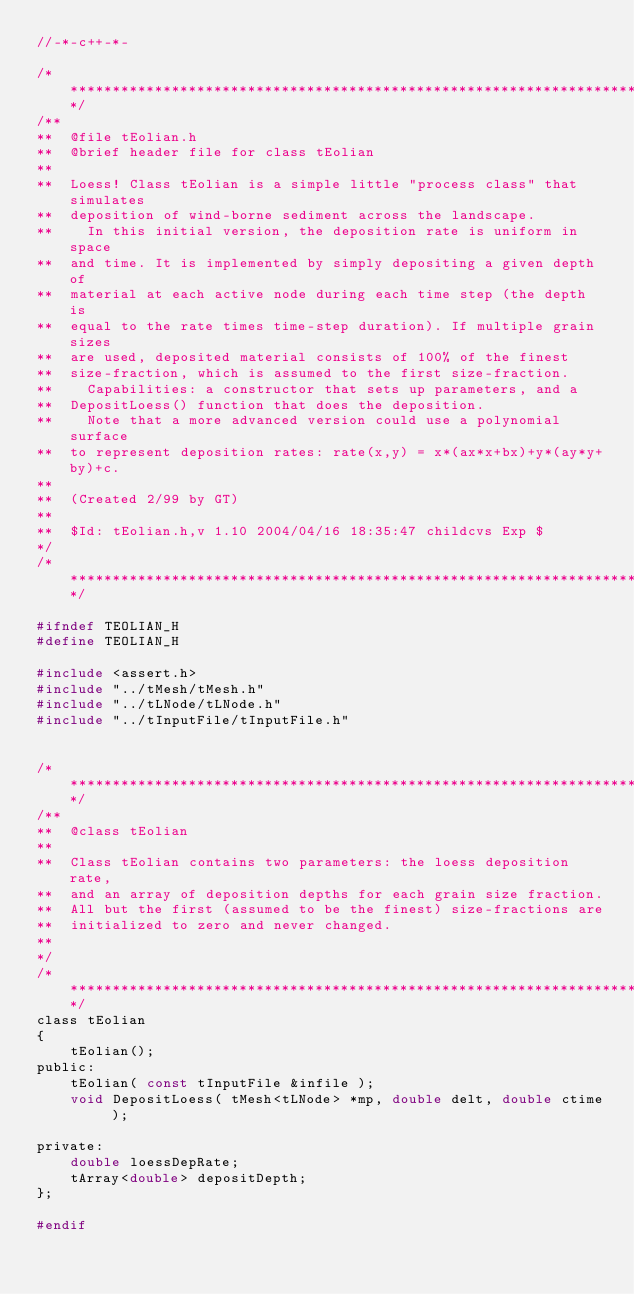<code> <loc_0><loc_0><loc_500><loc_500><_C_>//-*-c++-*- 

/**************************************************************************/
/**
**  @file tEolian.h
**  @brief header file for class tEolian
**
**  Loess! Class tEolian is a simple little "process class" that simulates
**  deposition of wind-borne sediment across the landscape.
**    In this initial version, the deposition rate is uniform in space
**  and time. It is implemented by simply depositing a given depth of
**  material at each active node during each time step (the depth is
**  equal to the rate times time-step duration). If multiple grain sizes
**  are used, deposited material consists of 100% of the finest
**  size-fraction, which is assumed to the first size-fraction.
**    Capabilities: a constructor that sets up parameters, and a
**  DepositLoess() function that does the deposition.
**    Note that a more advanced version could use a polynomial surface
**  to represent deposition rates: rate(x,y) = x*(ax*x+bx)+y*(ay*y+by)+c.
**
**  (Created 2/99 by GT)
**
**  $Id: tEolian.h,v 1.10 2004/04/16 18:35:47 childcvs Exp $
*/
/**************************************************************************/

#ifndef TEOLIAN_H
#define TEOLIAN_H

#include <assert.h>
#include "../tMesh/tMesh.h"
#include "../tLNode/tLNode.h"
#include "../tInputFile/tInputFile.h"


/**************************************************************************/
/**
**  @class tEolian
**
**  Class tEolian contains two parameters: the loess deposition rate,
**  and an array of deposition depths for each grain size fraction.
**  All but the first (assumed to be the finest) size-fractions are
**  initialized to zero and never changed.
**
*/
/**************************************************************************/
class tEolian
{
    tEolian();
public:
    tEolian( const tInputFile &infile );
    void DepositLoess( tMesh<tLNode> *mp, double delt, double ctime );

private:
    double loessDepRate;
    tArray<double> depositDepth;
};

#endif
</code> 